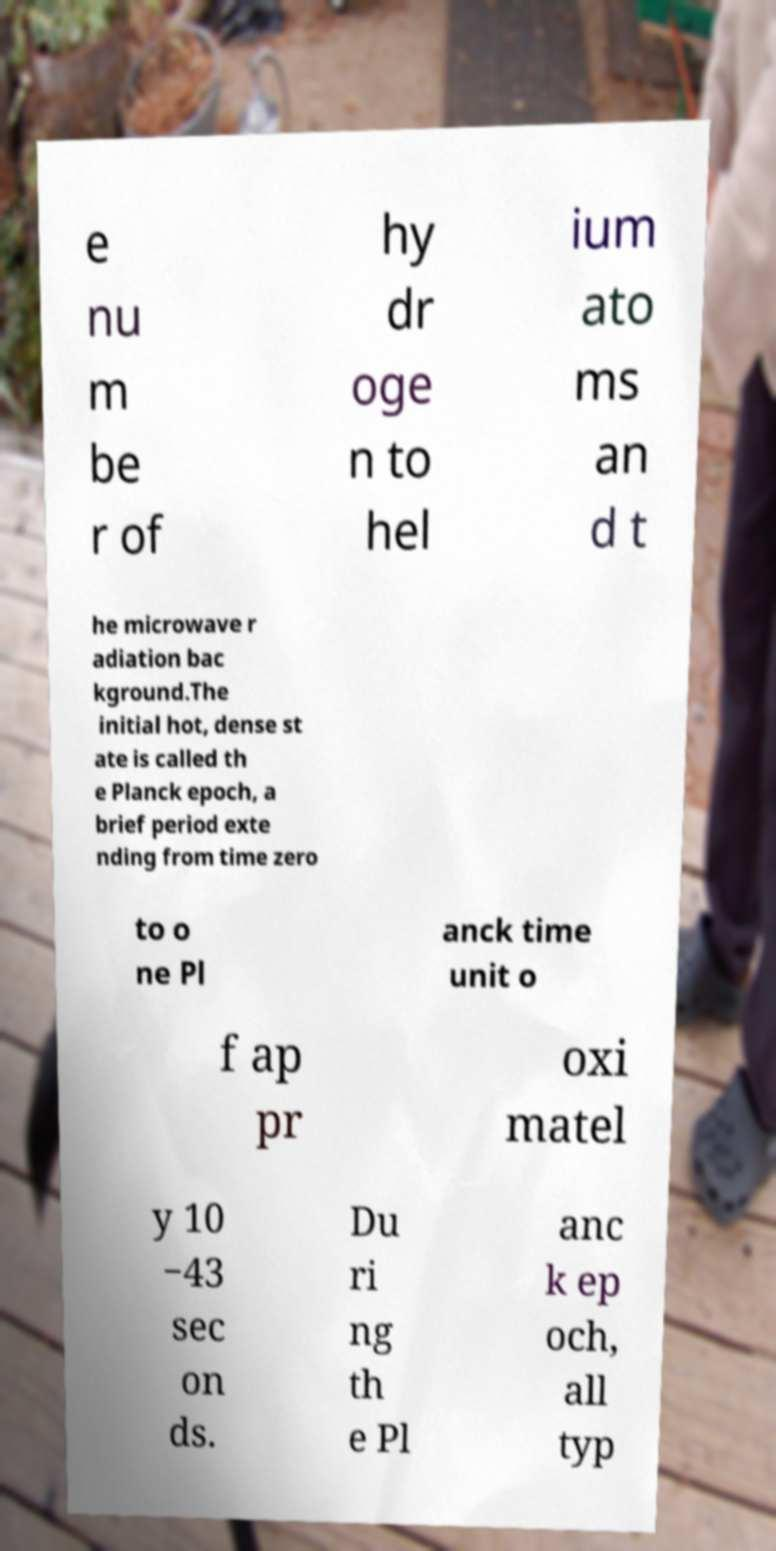Please identify and transcribe the text found in this image. e nu m be r of hy dr oge n to hel ium ato ms an d t he microwave r adiation bac kground.The initial hot, dense st ate is called th e Planck epoch, a brief period exte nding from time zero to o ne Pl anck time unit o f ap pr oxi matel y 10 −43 sec on ds. Du ri ng th e Pl anc k ep och, all typ 